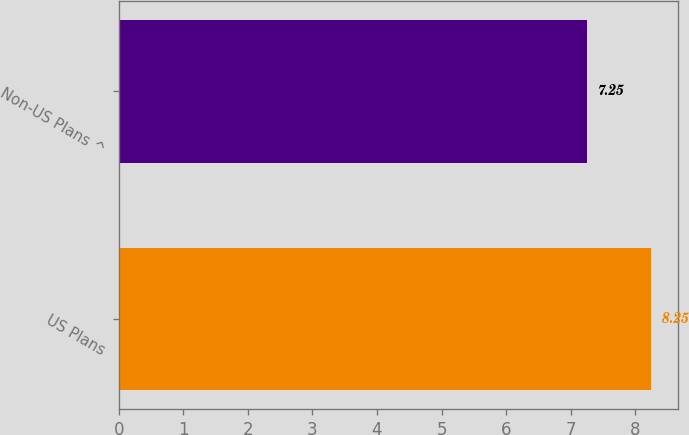<chart> <loc_0><loc_0><loc_500><loc_500><bar_chart><fcel>US Plans<fcel>Non-US Plans ^<nl><fcel>8.25<fcel>7.25<nl></chart> 